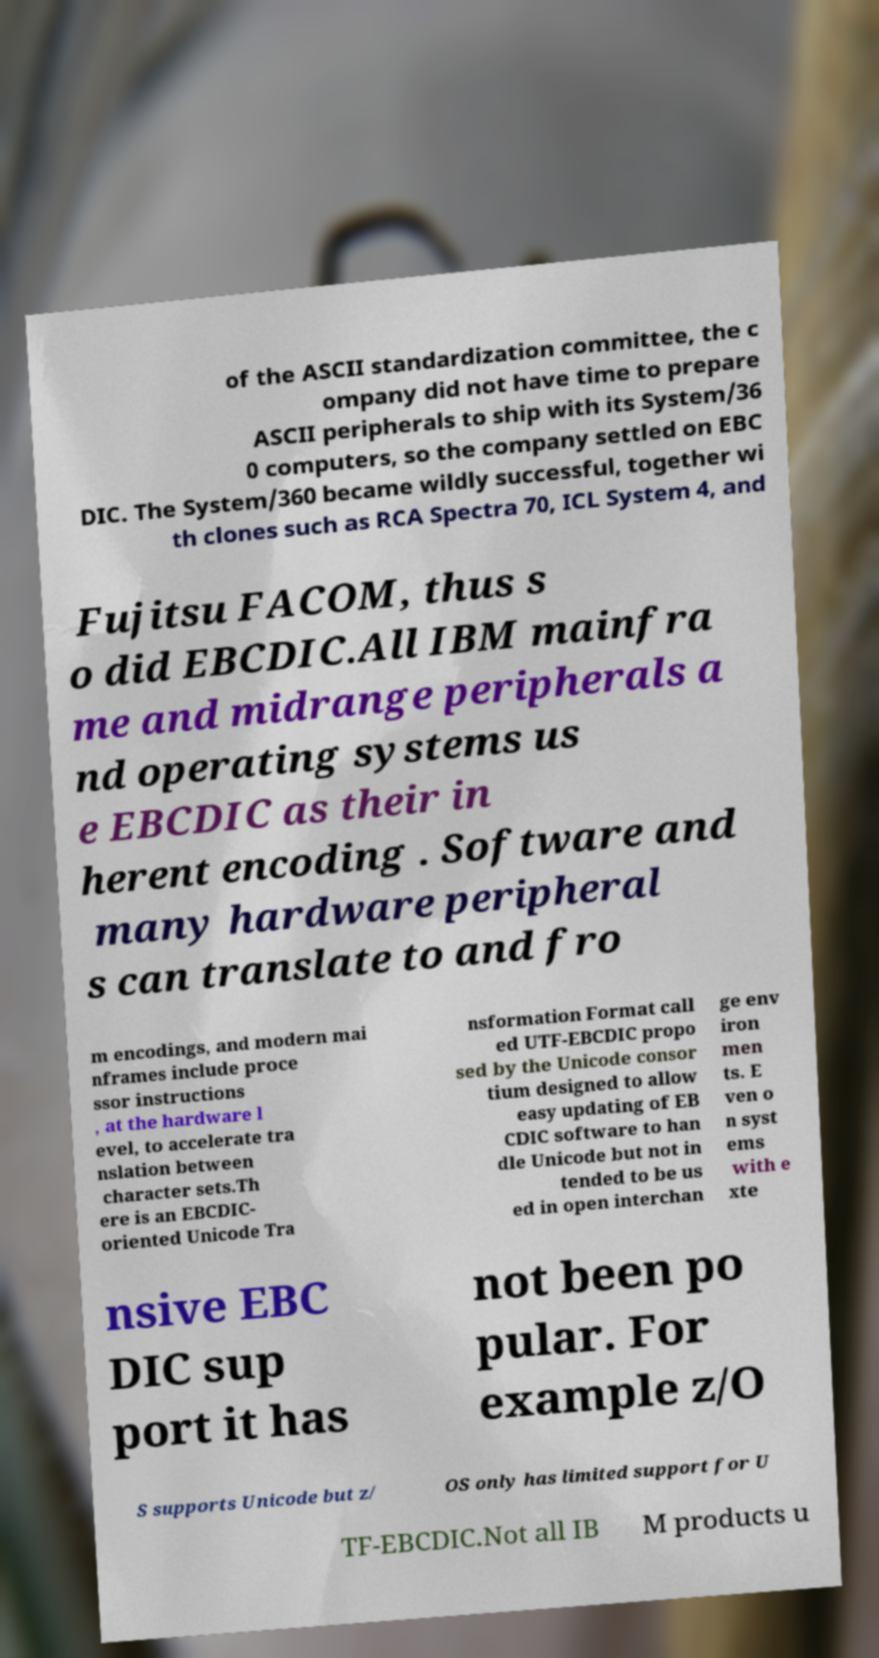Please read and relay the text visible in this image. What does it say? of the ASCII standardization committee, the c ompany did not have time to prepare ASCII peripherals to ship with its System/36 0 computers, so the company settled on EBC DIC. The System/360 became wildly successful, together wi th clones such as RCA Spectra 70, ICL System 4, and Fujitsu FACOM, thus s o did EBCDIC.All IBM mainfra me and midrange peripherals a nd operating systems us e EBCDIC as their in herent encoding . Software and many hardware peripheral s can translate to and fro m encodings, and modern mai nframes include proce ssor instructions , at the hardware l evel, to accelerate tra nslation between character sets.Th ere is an EBCDIC- oriented Unicode Tra nsformation Format call ed UTF-EBCDIC propo sed by the Unicode consor tium designed to allow easy updating of EB CDIC software to han dle Unicode but not in tended to be us ed in open interchan ge env iron men ts. E ven o n syst ems with e xte nsive EBC DIC sup port it has not been po pular. For example z/O S supports Unicode but z/ OS only has limited support for U TF-EBCDIC.Not all IB M products u 